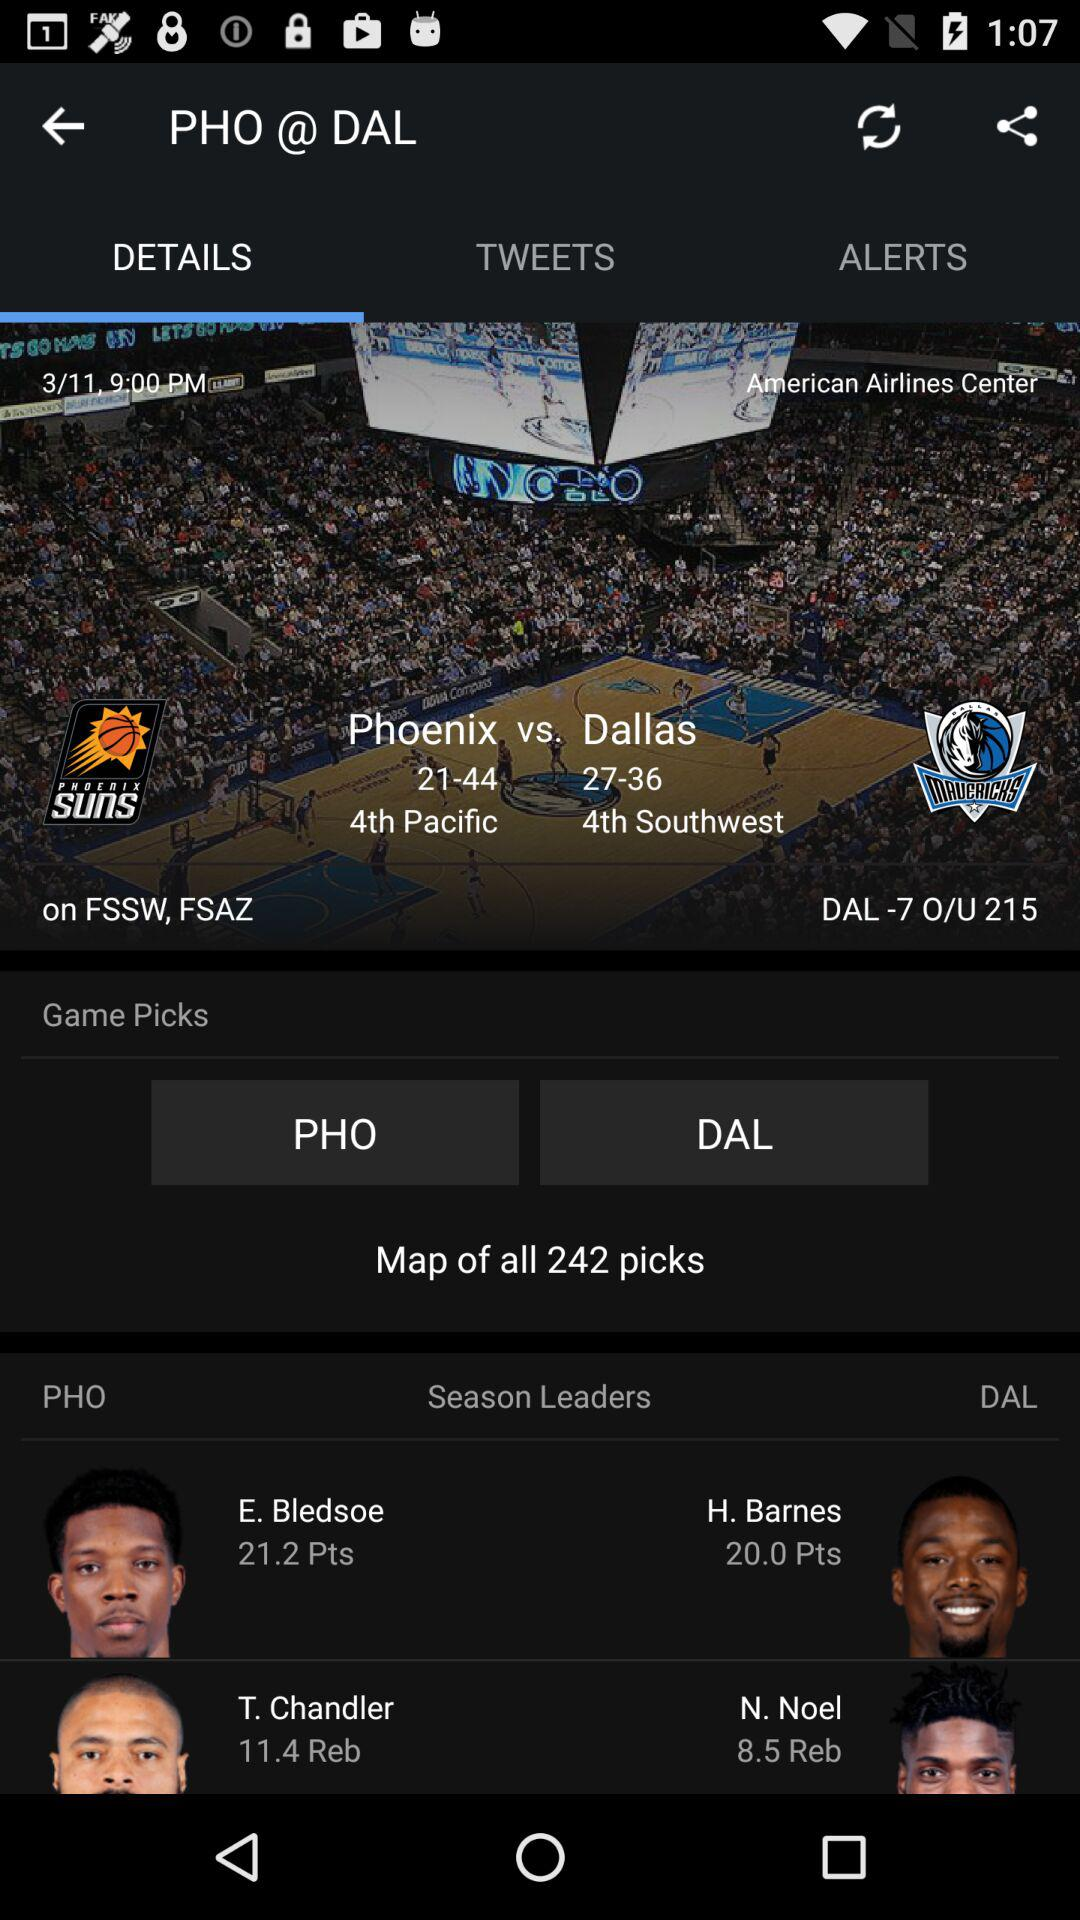How many picks are there on the screen? There are 242 picks on the screen. 